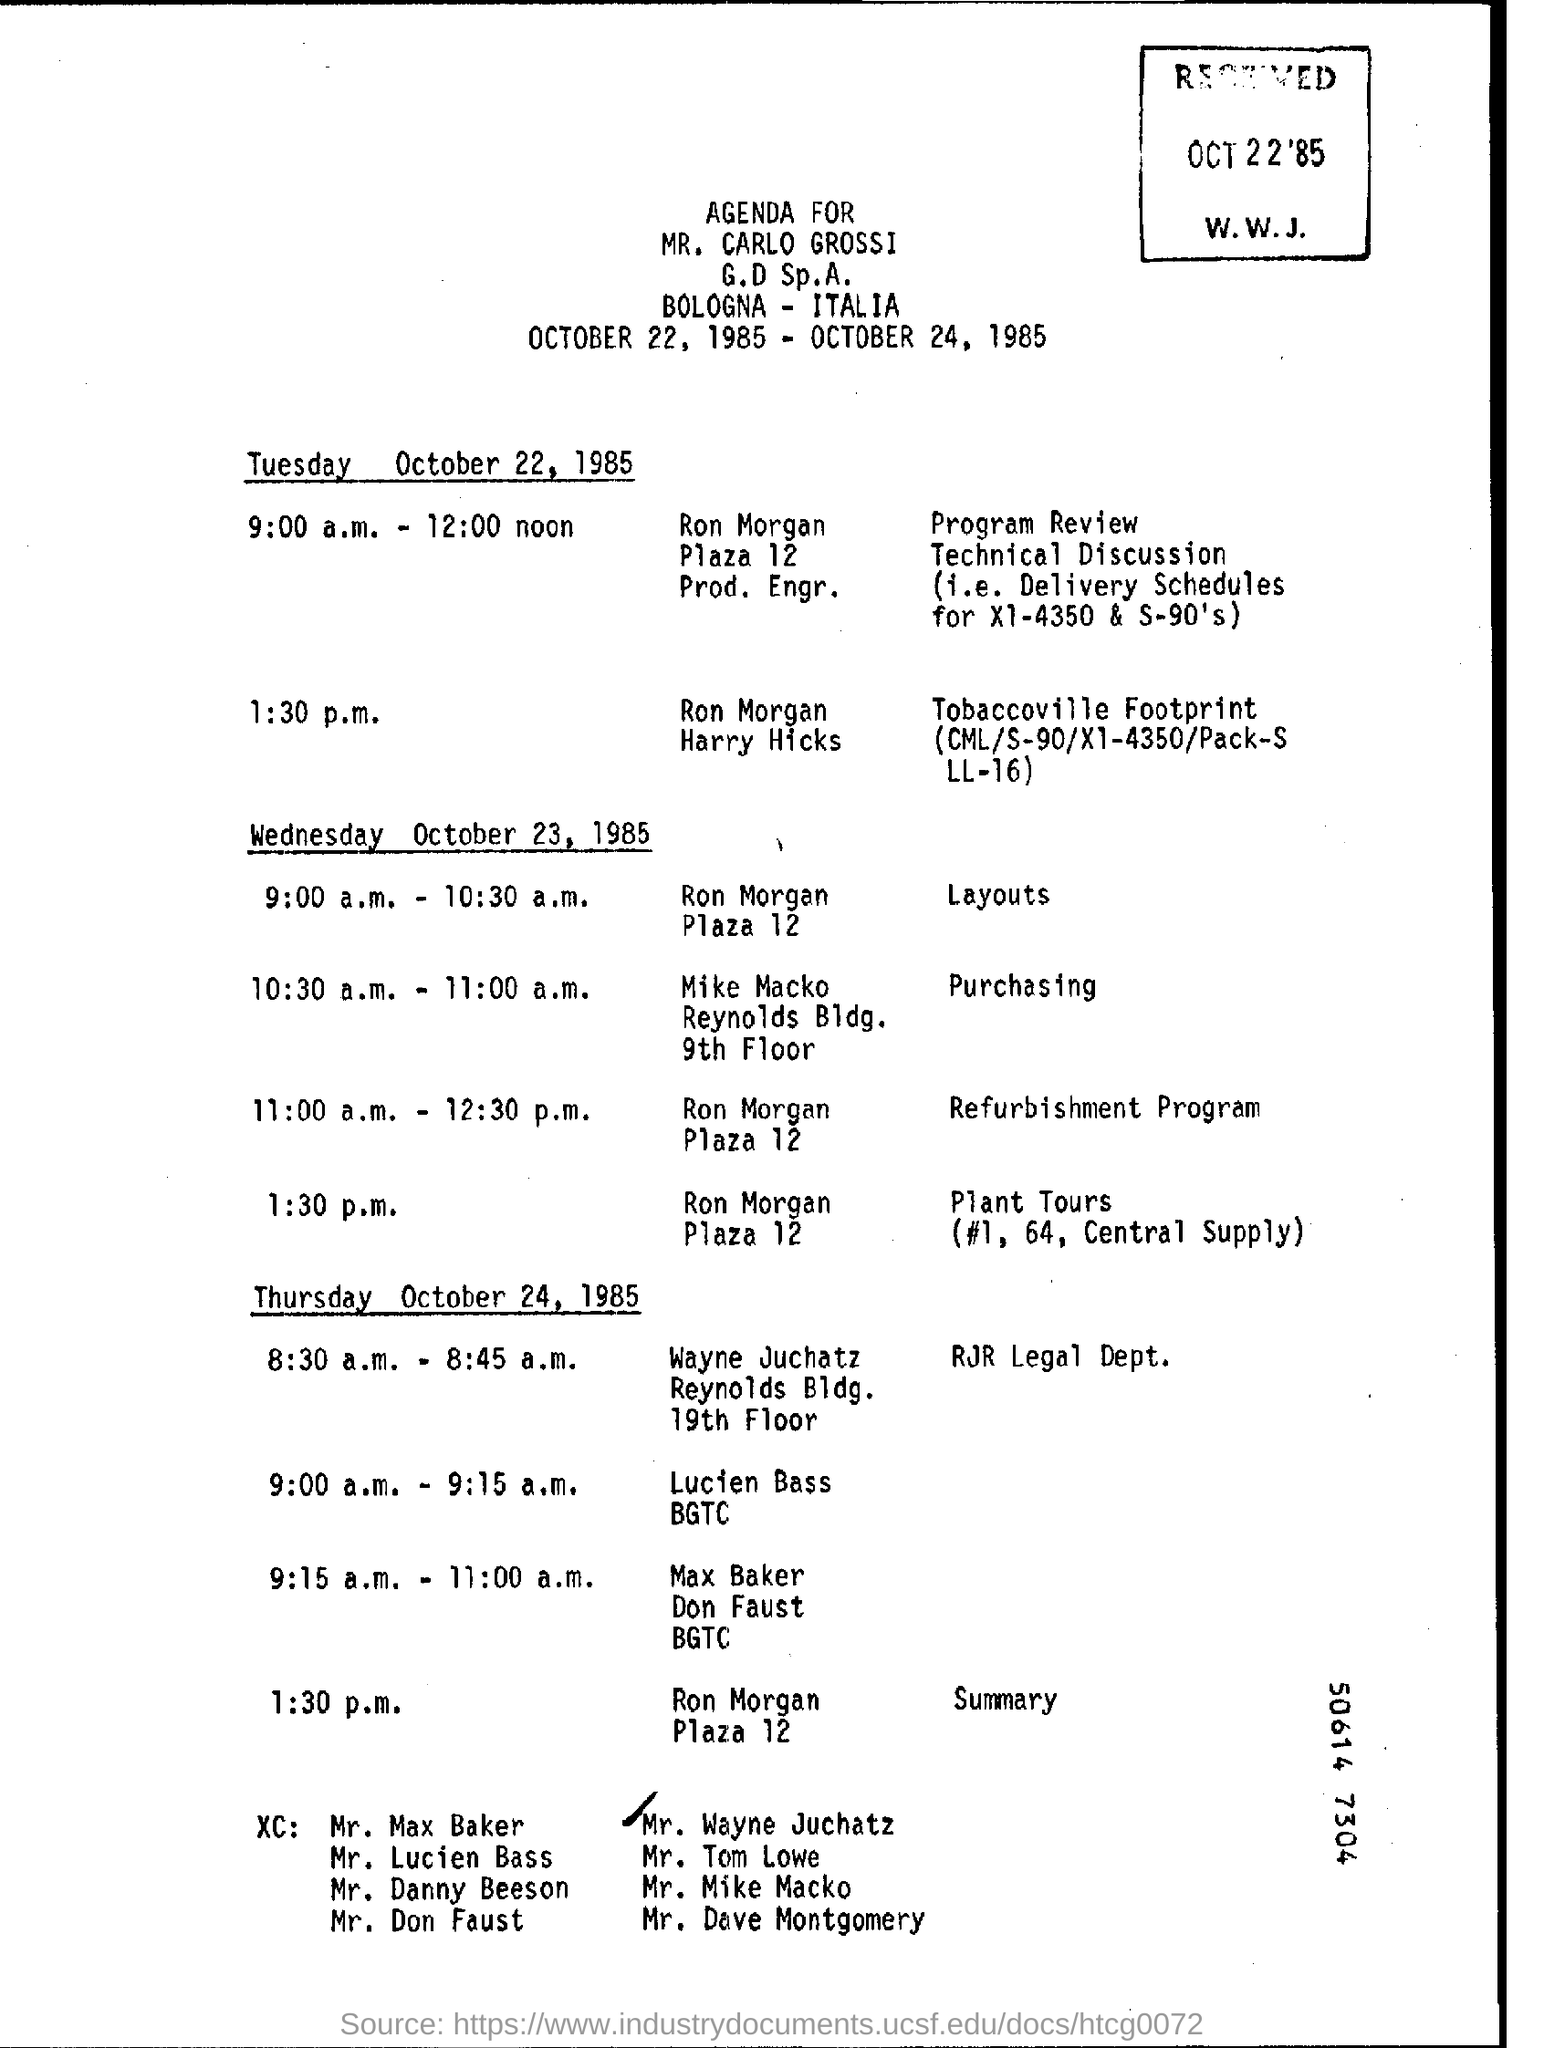AGENDA for the progarm fom which date to which date is mentioned here?
Give a very brief answer. October 22, 1985 - October 24, 1985. On Tuesday "Program Review" is at what time?
Keep it short and to the point. 9:00 a.m. - 12:00 noon. "Layouts" is at what time on wednesday?
Make the answer very short. 9:00 a.m. - 10:30 a.m. "Purchasing" is at what time on wednesday?
Your answer should be compact. 10:30 a.m. - 11:00 a.m. "Refurbishment Program" is at what time on wednesday?
Your answer should be compact. 11:00 a.m. - 12:30 p.m. "Plant Tours" is at what time on wednesday?
Provide a short and direct response. 1:30 p.m. "Summary" is at what time on thursday?
Provide a succinct answer. 1:30 p.m. Which day is October 24, 1985?
Offer a terse response. Thursday. "AGENDA FOR" whom is mentioned at the top of the page?
Make the answer very short. MR. CARLO GROSSI. 